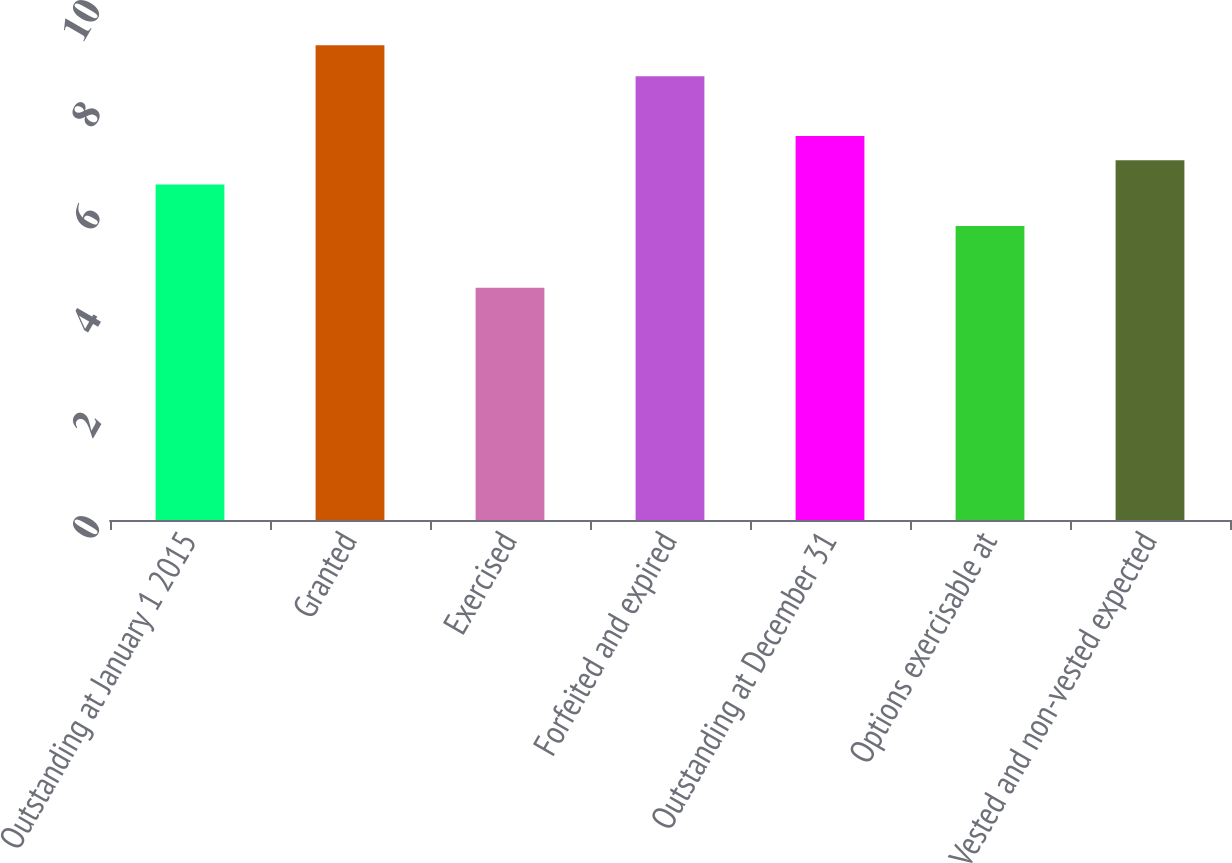Convert chart to OTSL. <chart><loc_0><loc_0><loc_500><loc_500><bar_chart><fcel>Outstanding at January 1 2015<fcel>Granted<fcel>Exercised<fcel>Forfeited and expired<fcel>Outstanding at December 31<fcel>Options exercisable at<fcel>Vested and non-vested expected<nl><fcel>6.5<fcel>9.2<fcel>4.5<fcel>8.6<fcel>7.44<fcel>5.7<fcel>6.97<nl></chart> 